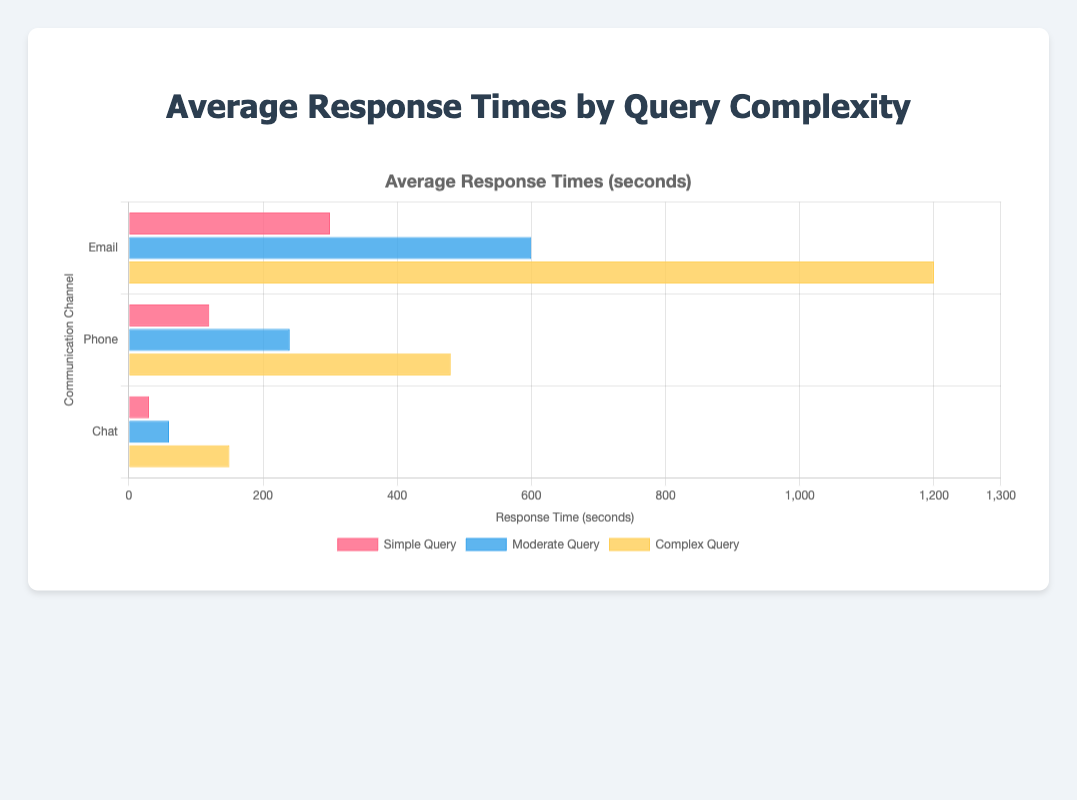What is the average response time for a simple query over all communication channels? To find the average response time for a simple query across all channels, sum the response times for Email (300s), Phone (120s), and Chat (30s). Then, divide by the number of channels (3). So, (300 + 120 + 30) / 3 = 450 / 3 = 150 seconds
Answer: 150 seconds Which communication channel has the highest response time for complex queries? Comparing the response times for complex queries: Email (1200s), Phone (480s), and Chat (150s), we see that Email has the highest response time.
Answer: Email How much shorter, in seconds, is the response time for moderate queries on Chat compared to Email? The response time for moderate queries on Chat is 60 seconds, while on Email, it is 600 seconds. The difference is 600 - 60 = 540 seconds.
Answer: 540 seconds Which communication channel has the lowest average response time for all levels of query complexity combined? To find the lowest average response time, calculate the average response times for each channel. For Email: (300 + 600 + 1200) / 3 = 2100 / 3 = 700 seconds; For Phone: (120 + 240 + 480) / 3 = 840 / 3 = 280 seconds; For Chat: (30 + 60 + 150) / 3 = 240 / 3 = 80 seconds. Chat has the lowest average response time.
Answer: Chat By what factor does the response time for a complex query on Email exceed the response time for a simple query on Phone? The response time for a complex query on Email is 1200 seconds, and for a simple query on Phone, it is 120 seconds. The factor is 1200 / 120 = 10.
Answer: 10 What is the total response time for all query types combined for the Phone channel? Sum the response times for all queries on the Phone channel: 120 + 240 + 480 = 840 seconds.
Answer: 840 seconds For which communication channel does the response time increase the most as query complexity increases from Simple to Complex? Calculate the increase for each channel: Email increases by 1200 - 300 = 900 seconds, Phone increases by 480 - 120 = 360 seconds, and Chat increases by 150 - 30 = 120 seconds. The Email channel sees the greatest increase.
Answer: Email 